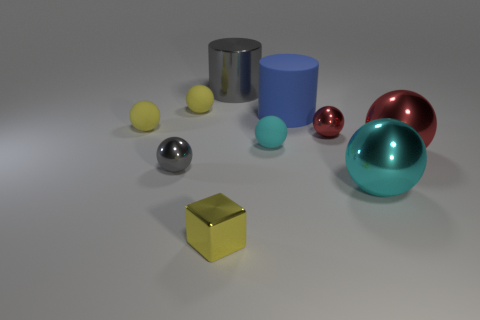Subtract all red spheres. How many spheres are left? 5 Subtract all yellow spheres. How many spheres are left? 5 Subtract 1 balls. How many balls are left? 6 Subtract all yellow spheres. Subtract all cyan cubes. How many spheres are left? 5 Subtract all balls. How many objects are left? 3 Add 8 tiny yellow matte things. How many tiny yellow matte things are left? 10 Add 6 gray objects. How many gray objects exist? 8 Subtract 0 green cylinders. How many objects are left? 10 Subtract all small things. Subtract all large blue metallic blocks. How many objects are left? 4 